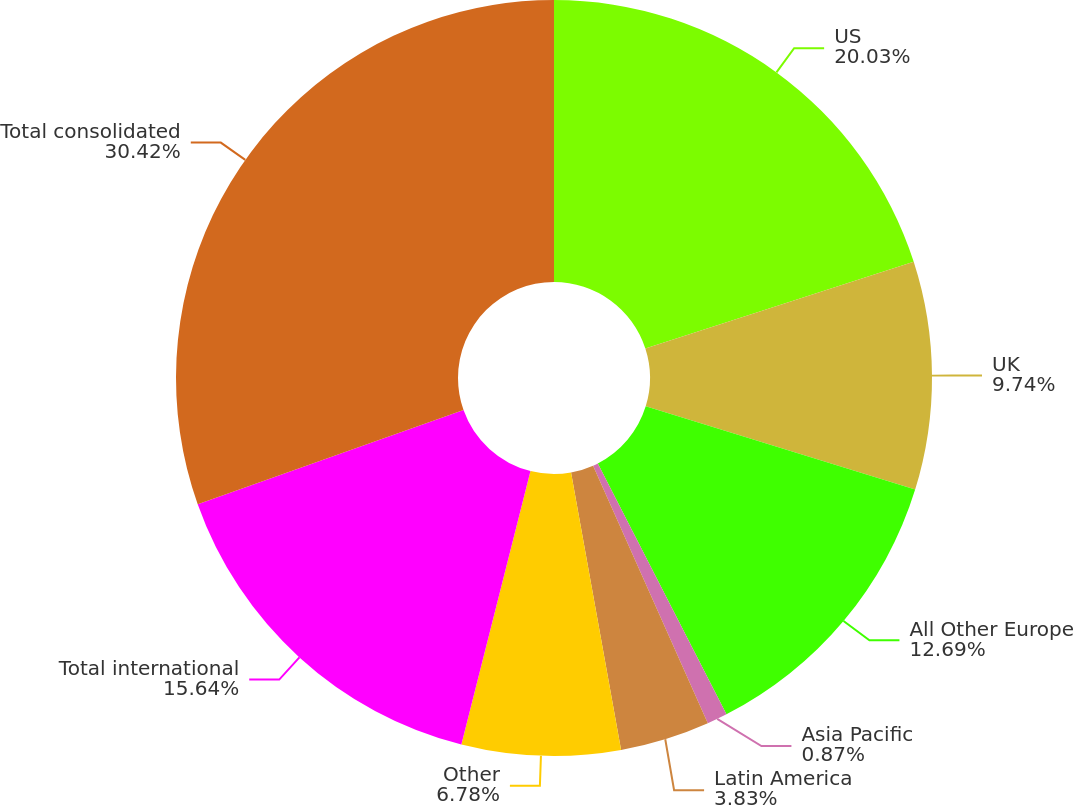Convert chart to OTSL. <chart><loc_0><loc_0><loc_500><loc_500><pie_chart><fcel>US<fcel>UK<fcel>All Other Europe<fcel>Asia Pacific<fcel>Latin America<fcel>Other<fcel>Total international<fcel>Total consolidated<nl><fcel>20.03%<fcel>9.74%<fcel>12.69%<fcel>0.87%<fcel>3.83%<fcel>6.78%<fcel>15.64%<fcel>30.42%<nl></chart> 